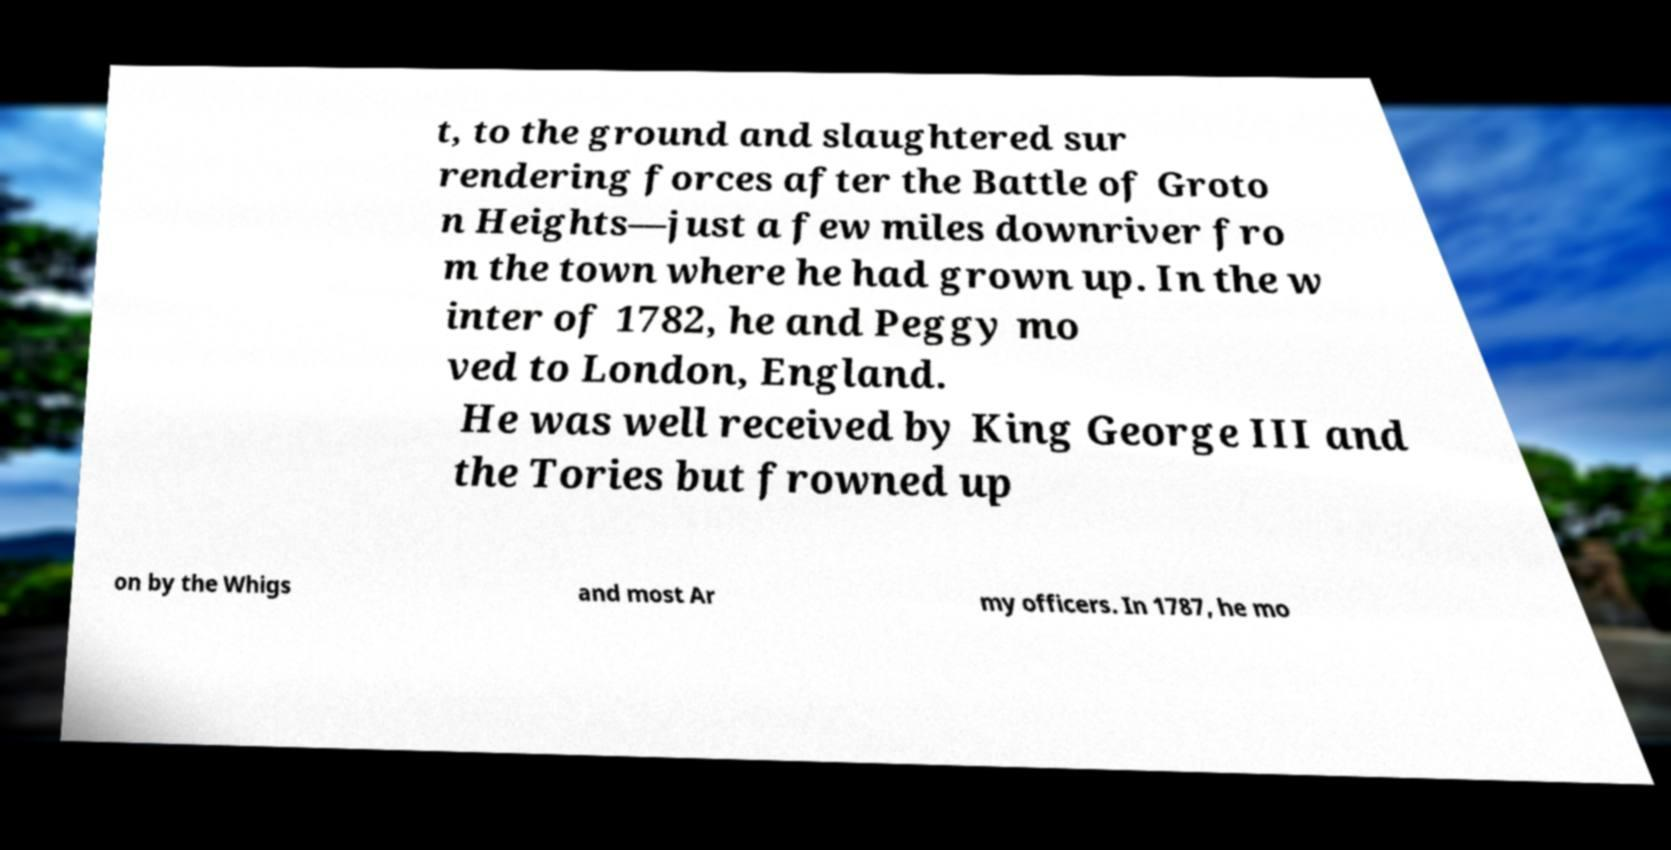I need the written content from this picture converted into text. Can you do that? t, to the ground and slaughtered sur rendering forces after the Battle of Groto n Heights—just a few miles downriver fro m the town where he had grown up. In the w inter of 1782, he and Peggy mo ved to London, England. He was well received by King George III and the Tories but frowned up on by the Whigs and most Ar my officers. In 1787, he mo 